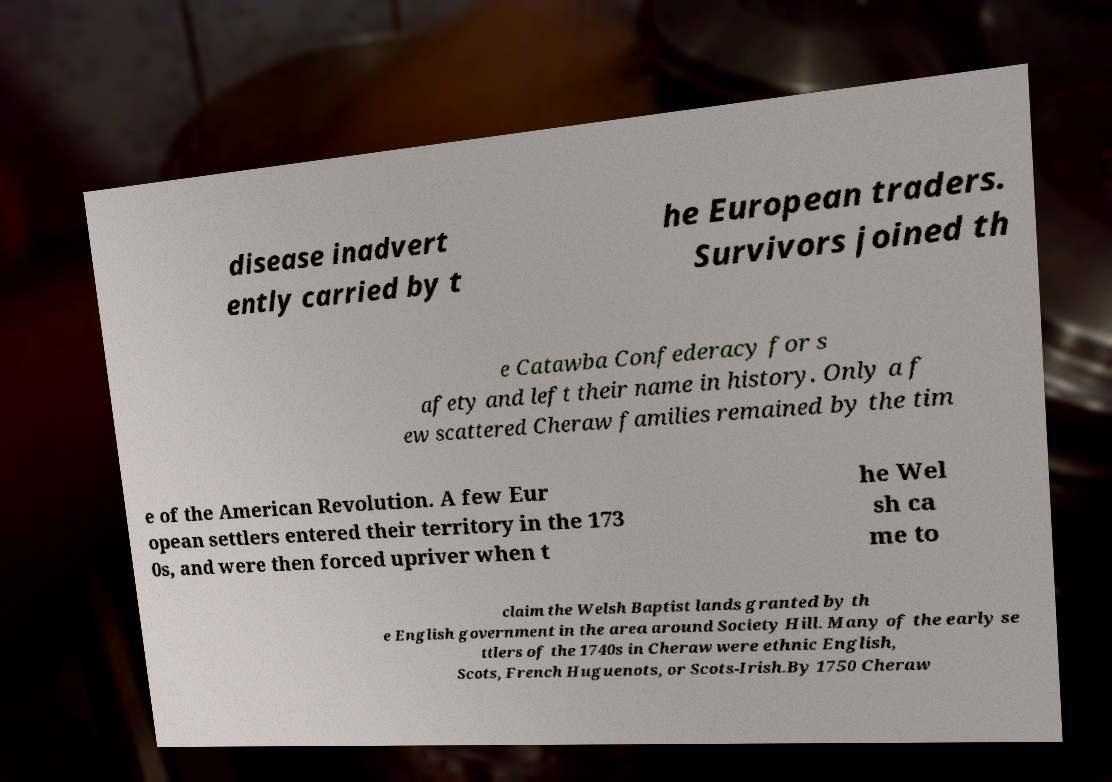Could you extract and type out the text from this image? disease inadvert ently carried by t he European traders. Survivors joined th e Catawba Confederacy for s afety and left their name in history. Only a f ew scattered Cheraw families remained by the tim e of the American Revolution. A few Eur opean settlers entered their territory in the 173 0s, and were then forced upriver when t he Wel sh ca me to claim the Welsh Baptist lands granted by th e English government in the area around Society Hill. Many of the early se ttlers of the 1740s in Cheraw were ethnic English, Scots, French Huguenots, or Scots-Irish.By 1750 Cheraw 